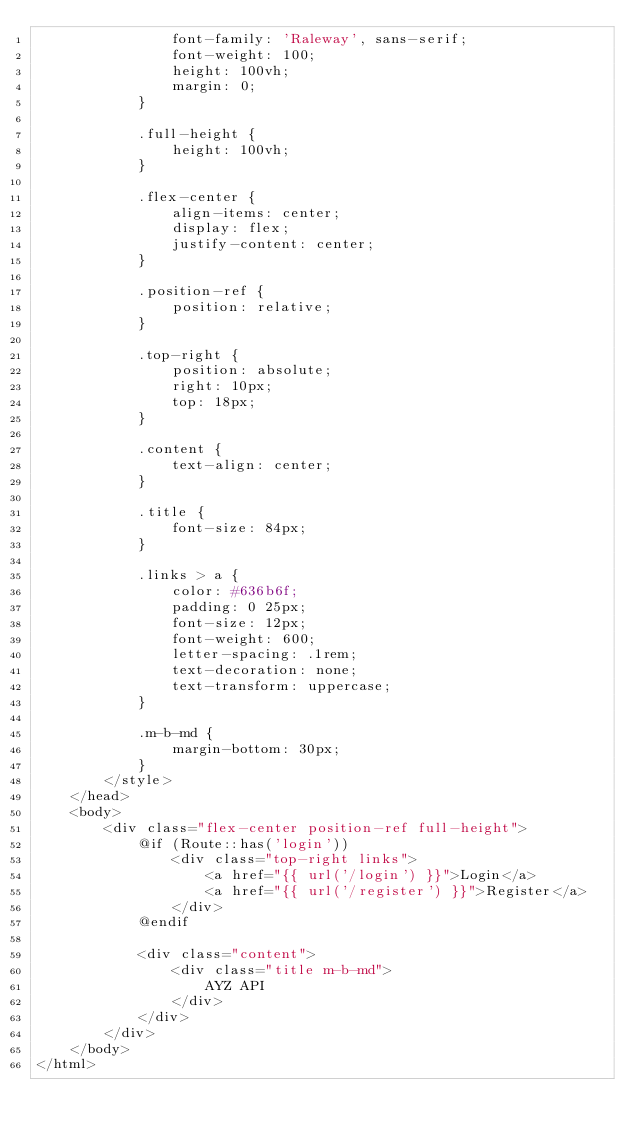<code> <loc_0><loc_0><loc_500><loc_500><_PHP_>                font-family: 'Raleway', sans-serif;
                font-weight: 100;
                height: 100vh;
                margin: 0;
            }

            .full-height {
                height: 100vh;
            }

            .flex-center {
                align-items: center;
                display: flex;
                justify-content: center;
            }

            .position-ref {
                position: relative;
            }

            .top-right {
                position: absolute;
                right: 10px;
                top: 18px;
            }

            .content {
                text-align: center;
            }

            .title {
                font-size: 84px;
            }

            .links > a {
                color: #636b6f;
                padding: 0 25px;
                font-size: 12px;
                font-weight: 600;
                letter-spacing: .1rem;
                text-decoration: none;
                text-transform: uppercase;
            }

            .m-b-md {
                margin-bottom: 30px;
            }
        </style>
    </head>
    <body>
        <div class="flex-center position-ref full-height">
            @if (Route::has('login'))
                <div class="top-right links">
                    <a href="{{ url('/login') }}">Login</a>
                    <a href="{{ url('/register') }}">Register</a>
                </div>
            @endif

            <div class="content">
                <div class="title m-b-md">
                    AYZ API
                </div>
            </div>
        </div>
    </body>
</html>
</code> 